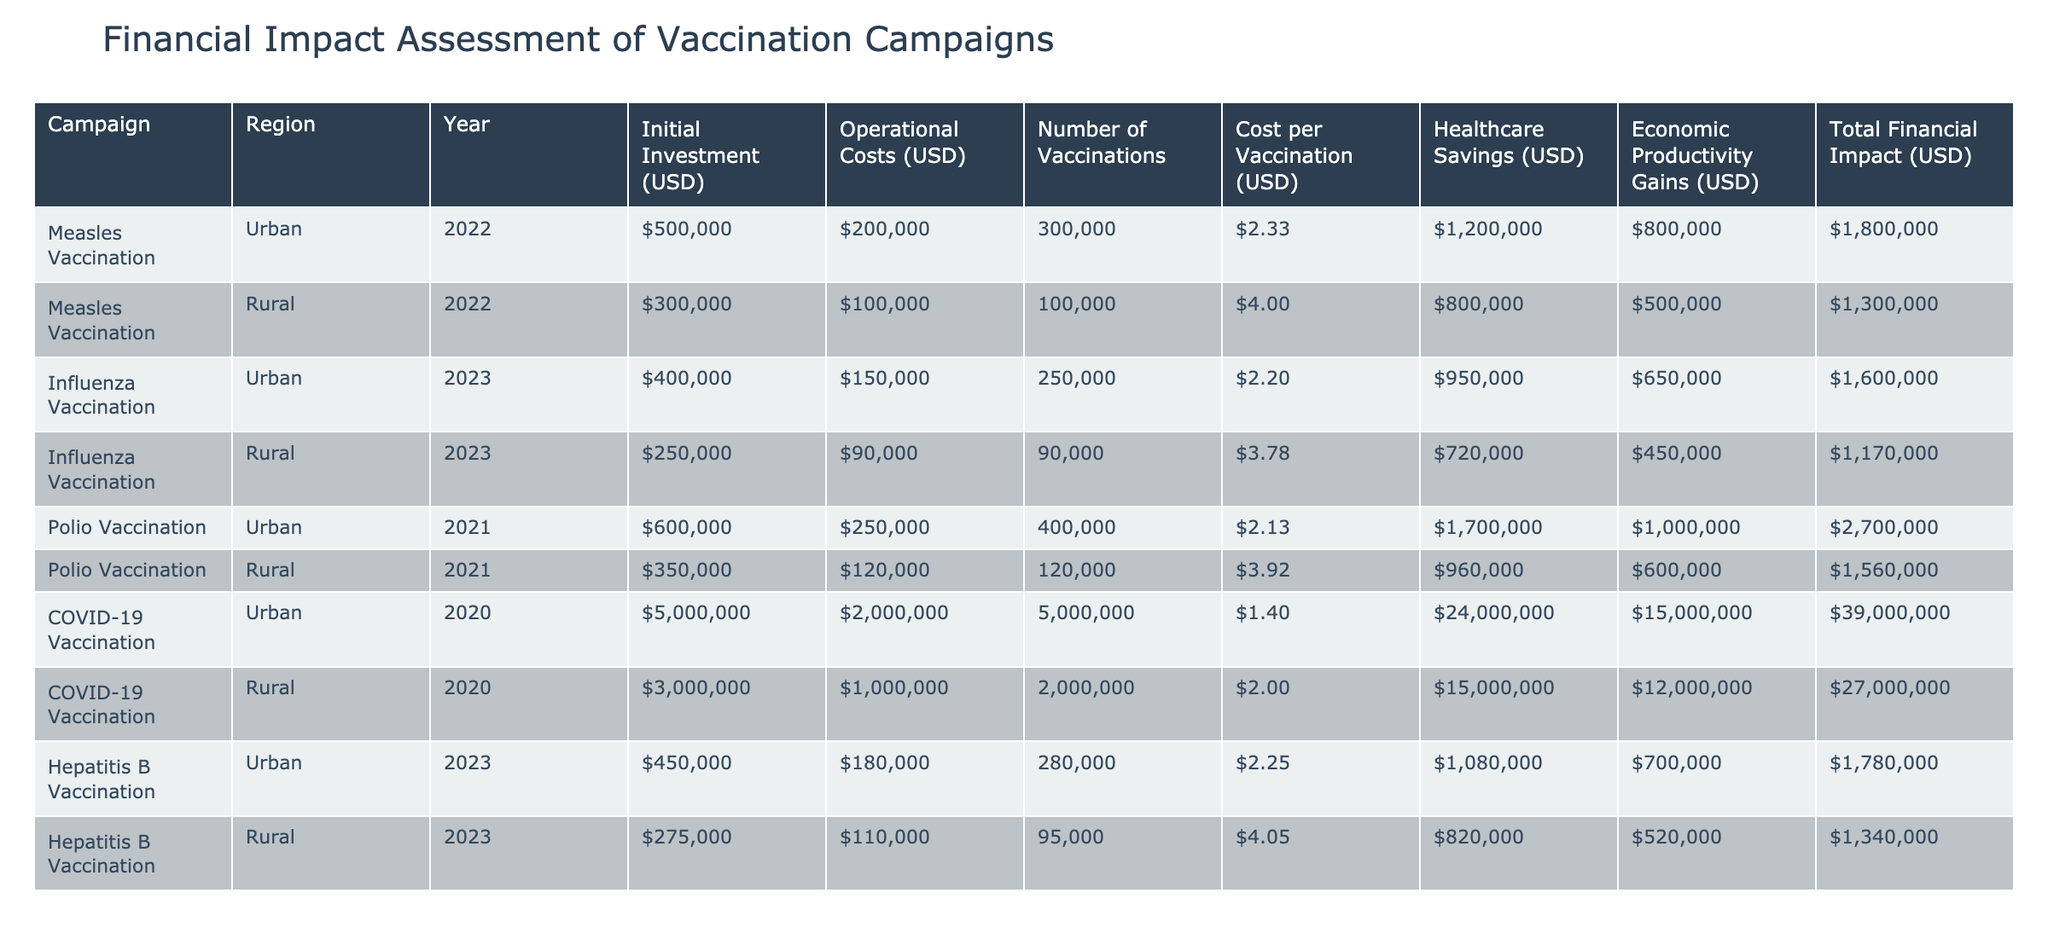What is the total financial impact of the COVID-19 vaccination campaign in urban areas? The table shows that the total financial impact of the COVID-19 vaccination campaign in urban areas is listed as $39,000,000 under Total Financial Impact (USD).
Answer: $39,000,000 Which vaccination campaign had the highest initial investment? By reviewing the Initial Investment (USD) column, the COVID-19 vaccination campaign in urban areas with an investment of $5,000,000 has the highest initial investment compared to all other campaigns.
Answer: $5,000,000 What is the average cost per vaccination for the rural measles vaccination campaign? The cost per vaccination for the rural measles vaccination campaign is $4.00 as specified in the Cost per Vaccination (USD) column. There is only one entry for this campaign in the rural area, so the average is the same.
Answer: $4.00 Did the influenza vaccination campaign in rural areas have more healthcare savings than operational costs? By comparing the Healthcare Savings (USD) of $720,000 with Operational Costs (USD) of $90,000, we see that healthcare savings exceed operational costs, confirming the statement is true.
Answer: Yes What is the difference in the total financial impact between the urban and rural polio vaccination campaigns? The total financial impact for the urban polio vaccination campaign is $2,700,000 and for the rural campaign is $1,560,000. The difference is calculated as $2,700,000 - $1,560,000 = $1,140,000.
Answer: $1,140,000 How many vaccinations were administered in total for the influenza vaccination campaigns across both urban and rural areas? The urban influenza vaccination campaign administered 250,000 vaccinations and the rural campaign administered 90,000 vaccinations. Therefore, the total is 250,000 + 90,000 = 340,000.
Answer: 340,000 Is it true that the economic productivity gains from the hepatitis B vaccination campaign in urban areas were greater than the healthcare savings? The hepatitis B vaccination campaign in urban areas shows economic productivity gains of $700,000 and healthcare savings of $1,080,000. Since $700,000 is less than $1,080,000, the statement is false.
Answer: No Which region had a lower cost per vaccination for hepatitis B vaccinations, urban or rural? For the hepatitis B vaccination, the cost per vaccination for urban areas is $2.25 and for rural areas is $4.05. Since $2.25 is lower than $4.05, the urban area had a lower cost per vaccination.
Answer: Urban 